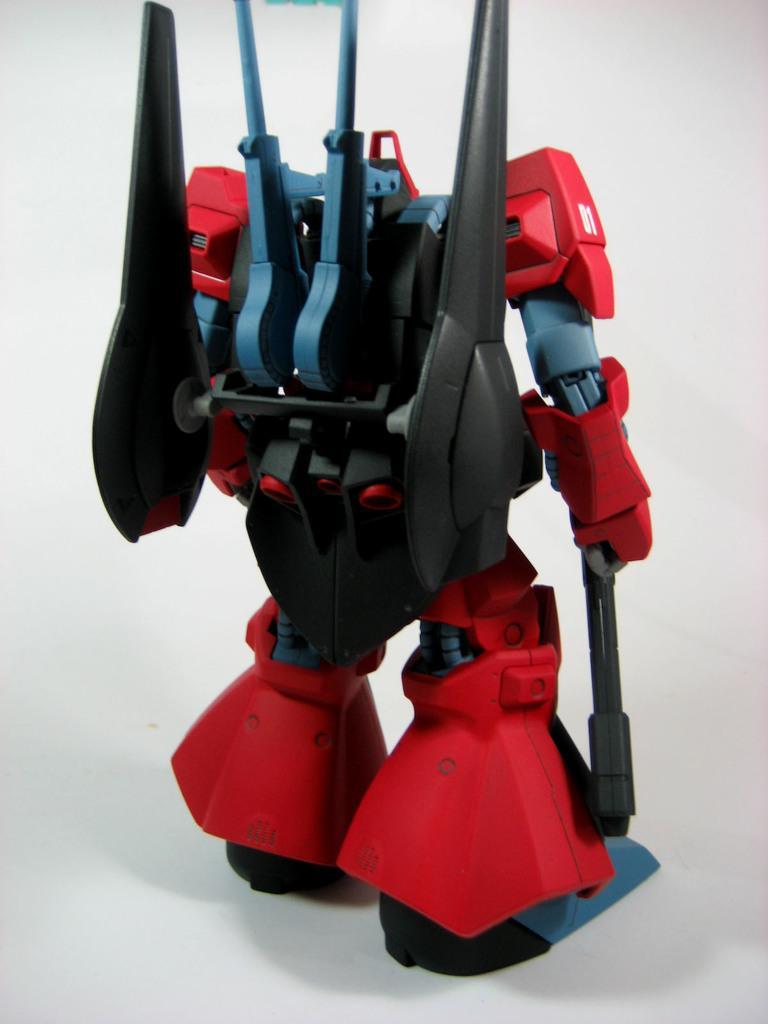Describe this image in one or two sentences. In this image we can see a toy robot. There is a white background. 